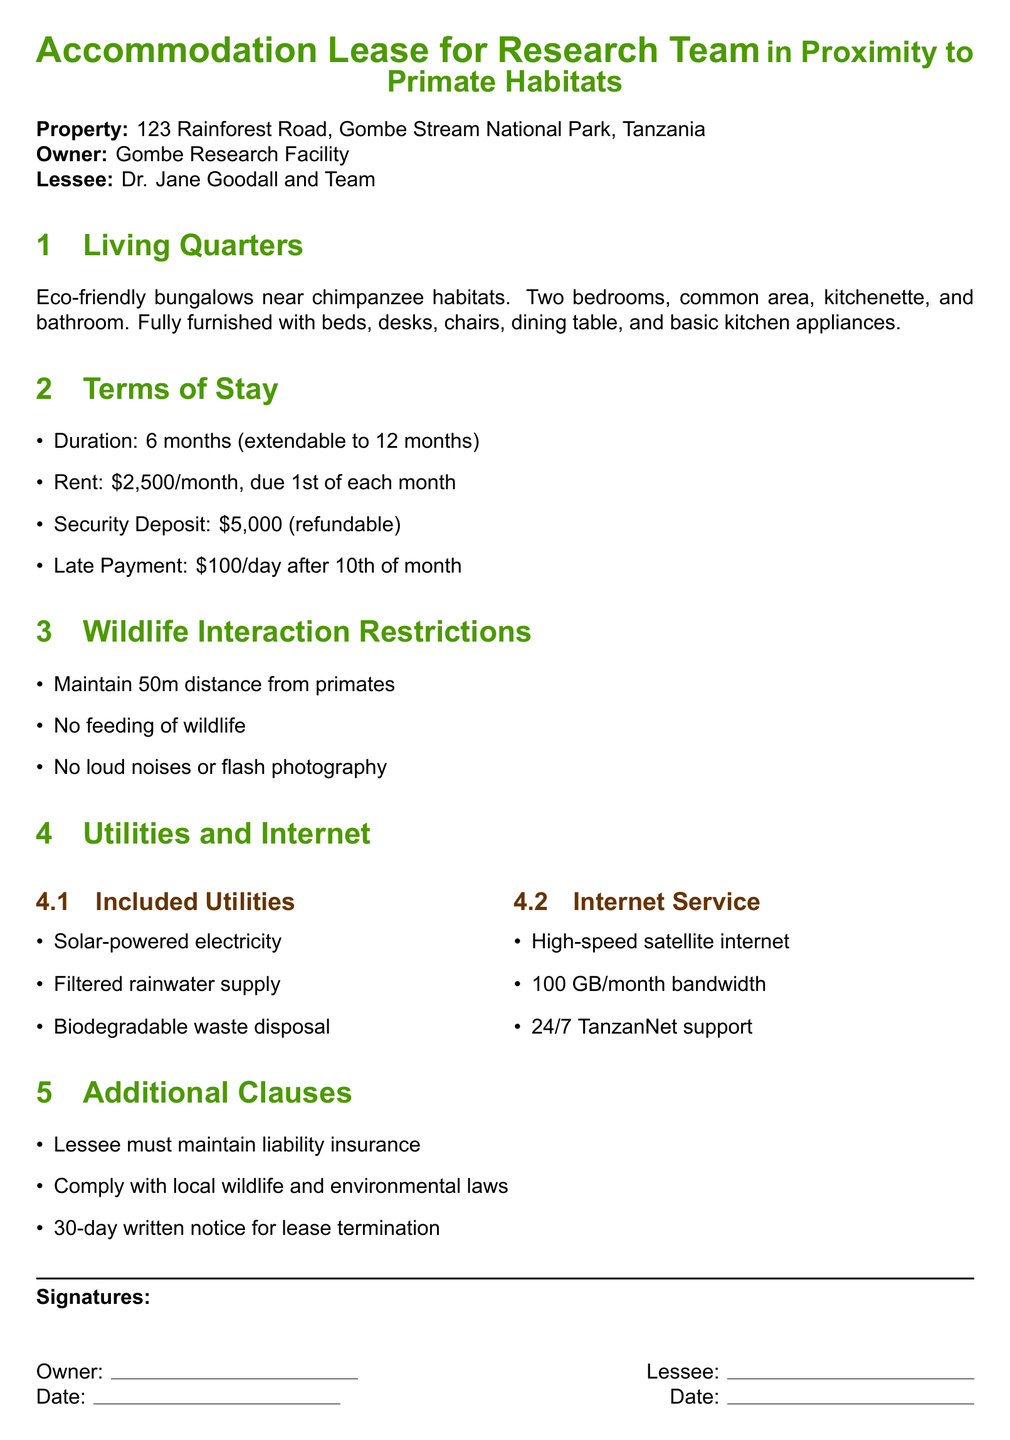What is the property address? The property address is stated at the beginning of the document as 123 Rainforest Road, Gombe Stream National Park, Tanzania.
Answer: 123 Rainforest Road, Gombe Stream National Park, Tanzania What is the monthly rent? The monthly rent is specified in the terms of stay section of the document as $2,500/month.
Answer: $2,500/month What is the length of the initial lease? The initial duration of the lease is mentioned as 6 months, with the possibility of extension.
Answer: 6 months What is the distance that must be maintained from primates? The wildlife interaction restrictions section states that a 50m distance must be maintained from primates.
Answer: 50m How many bedrooms are in the living quarters? The living quarters section specifies that there are two bedrooms in the bungalows.
Answer: Two bedrooms What is included in the utilities? A list of included utilities is provided, which includes solar-powered electricity, filtered rainwater supply, and biodegradable waste disposal.
Answer: Solar-powered electricity, filtered rainwater supply, biodegradable waste disposal What is the security deposit amount? The security deposit is stated to be $5,000 and is refundable.
Answer: $5,000 What type of internet service is provided? The internet service section of the document mentions high-speed satellite internet.
Answer: High-speed satellite internet What must the lessee maintain according to additional clauses? The additional clauses specify that the lessee must maintain liability insurance.
Answer: Liability insurance 